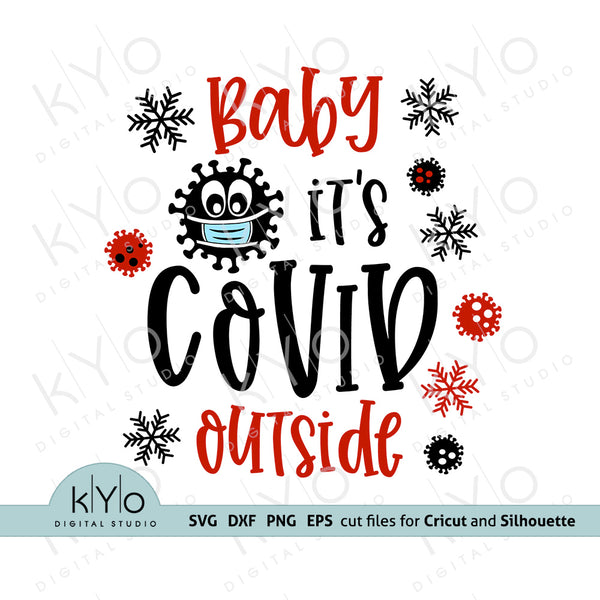How might using this image on various items affect people's attitude towards the ongoing pandemic? Using this image on items like clothing and home decor might serve dual purposes: first, as a humorous relief, making light of the restrictions and challenges faced during the pandemic; second, it could remind individuals of the continuous need for caution and health safety measures. The light-hearted nature could help reduce stress, while still keeping the seriousness of the health crisis at the forefront. It's a balance of acknowledging the reality with a touch of wit, which might help in normalizing mask-wearing and maintaining awareness about COVID-19 safety. 